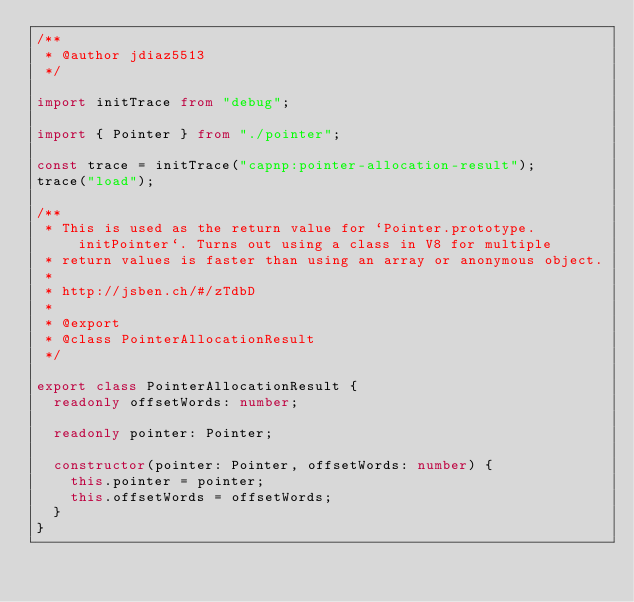<code> <loc_0><loc_0><loc_500><loc_500><_TypeScript_>/**
 * @author jdiaz5513
 */

import initTrace from "debug";

import { Pointer } from "./pointer";

const trace = initTrace("capnp:pointer-allocation-result");
trace("load");

/**
 * This is used as the return value for `Pointer.prototype.initPointer`. Turns out using a class in V8 for multiple
 * return values is faster than using an array or anonymous object.
 *
 * http://jsben.ch/#/zTdbD
 *
 * @export
 * @class PointerAllocationResult
 */

export class PointerAllocationResult {
  readonly offsetWords: number;

  readonly pointer: Pointer;

  constructor(pointer: Pointer, offsetWords: number) {
    this.pointer = pointer;
    this.offsetWords = offsetWords;
  }
}
</code> 